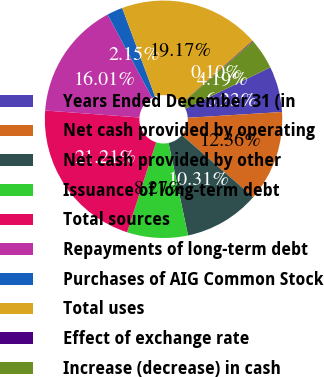<chart> <loc_0><loc_0><loc_500><loc_500><pie_chart><fcel>Years Ended December 31 (in<fcel>Net cash provided by operating<fcel>Net cash provided by other<fcel>Issuance of long-term debt<fcel>Total sources<fcel>Repayments of long-term debt<fcel>Purchases of AIG Common Stock<fcel>Total uses<fcel>Effect of exchange rate<fcel>Increase (decrease) in cash<nl><fcel>6.23%<fcel>12.36%<fcel>10.31%<fcel>8.27%<fcel>21.21%<fcel>16.01%<fcel>2.15%<fcel>19.17%<fcel>0.1%<fcel>4.19%<nl></chart> 